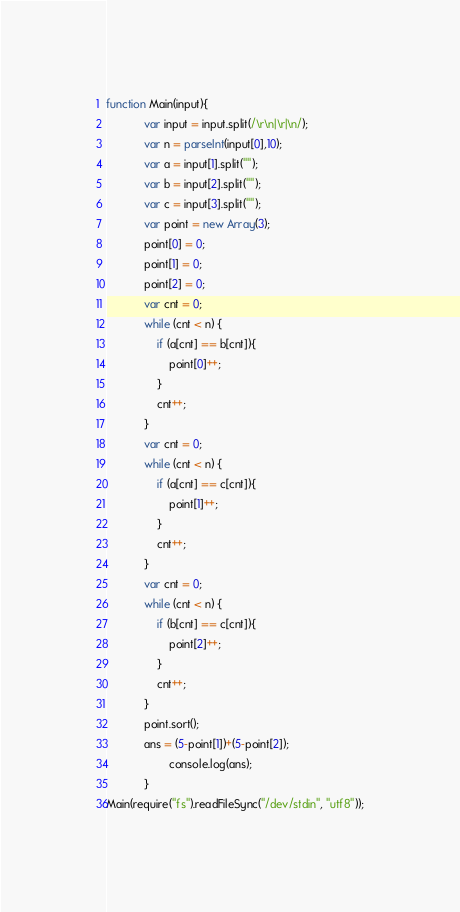<code> <loc_0><loc_0><loc_500><loc_500><_JavaScript_>function Main(input){
    		var input = input.split(/\r\n|\r|\n/);
        	var n = parseInt(input[0],10);
        	var a = input[1].split("");
        	var b = input[2].split("");
        	var c = input[3].split("");
        	var point = new Array(3);
        	point[0] = 0;
        	point[1] = 0;
        	point[2] = 0;
        	var cnt = 0;
        	while (cnt < n) {
        		if (a[cnt] == b[cnt]){
        			point[0]++;
        		}
        		cnt++; 
    		}
    		var cnt = 0;
    		while (cnt < n) {
        		if (a[cnt] == c[cnt]){
        			point[1]++;
        		}
        		cnt++; 
    		}
    		var cnt = 0;
    		while (cnt < n) {
        		if (b[cnt] == c[cnt]){
        			point[2]++;
        		}
        		cnt++; 
    		}
    		point.sort();
    		ans = (5-point[1])+(5-point[2]);
    		    	console.log(ans);
    		}
Main(require("fs").readFileSync("/dev/stdin", "utf8"));</code> 